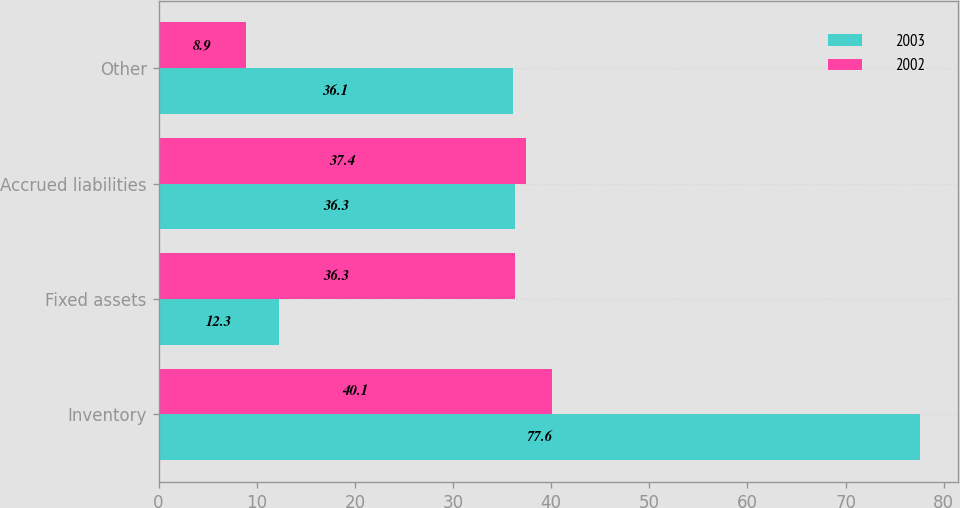<chart> <loc_0><loc_0><loc_500><loc_500><stacked_bar_chart><ecel><fcel>Inventory<fcel>Fixed assets<fcel>Accrued liabilities<fcel>Other<nl><fcel>2003<fcel>77.6<fcel>12.3<fcel>36.3<fcel>36.1<nl><fcel>2002<fcel>40.1<fcel>36.3<fcel>37.4<fcel>8.9<nl></chart> 